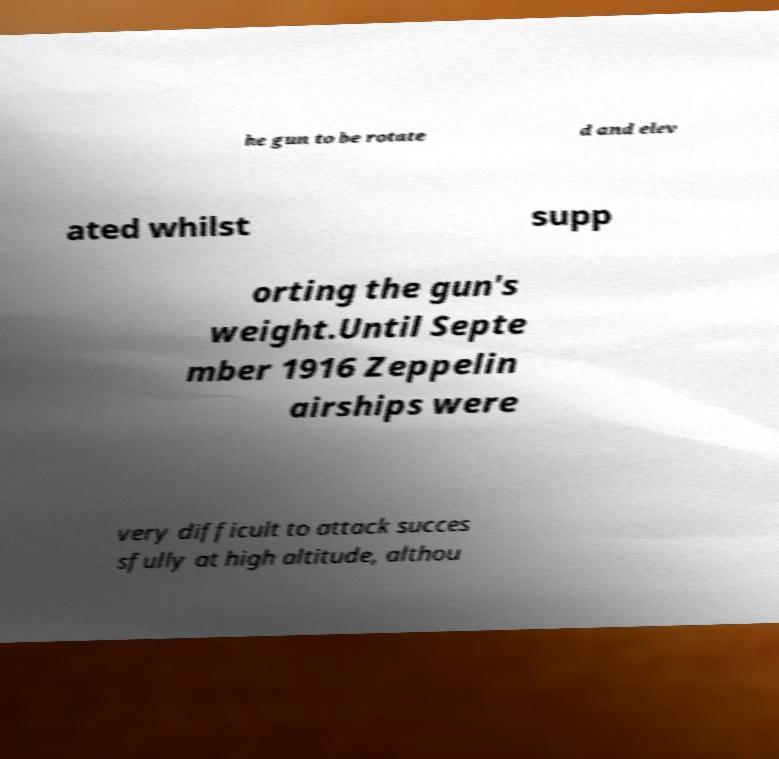Could you extract and type out the text from this image? he gun to be rotate d and elev ated whilst supp orting the gun's weight.Until Septe mber 1916 Zeppelin airships were very difficult to attack succes sfully at high altitude, althou 